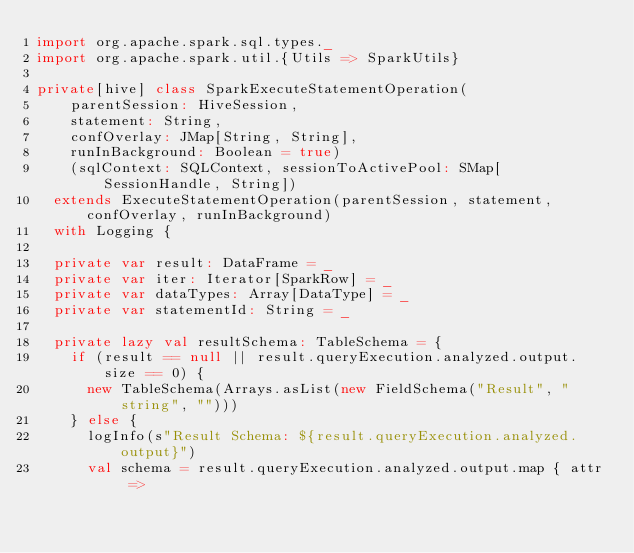<code> <loc_0><loc_0><loc_500><loc_500><_Scala_>import org.apache.spark.sql.types._
import org.apache.spark.util.{Utils => SparkUtils}

private[hive] class SparkExecuteStatementOperation(
    parentSession: HiveSession,
    statement: String,
    confOverlay: JMap[String, String],
    runInBackground: Boolean = true)
    (sqlContext: SQLContext, sessionToActivePool: SMap[SessionHandle, String])
  extends ExecuteStatementOperation(parentSession, statement, confOverlay, runInBackground)
  with Logging {

  private var result: DataFrame = _
  private var iter: Iterator[SparkRow] = _
  private var dataTypes: Array[DataType] = _
  private var statementId: String = _

  private lazy val resultSchema: TableSchema = {
    if (result == null || result.queryExecution.analyzed.output.size == 0) {
      new TableSchema(Arrays.asList(new FieldSchema("Result", "string", "")))
    } else {
      logInfo(s"Result Schema: ${result.queryExecution.analyzed.output}")
      val schema = result.queryExecution.analyzed.output.map { attr =></code> 